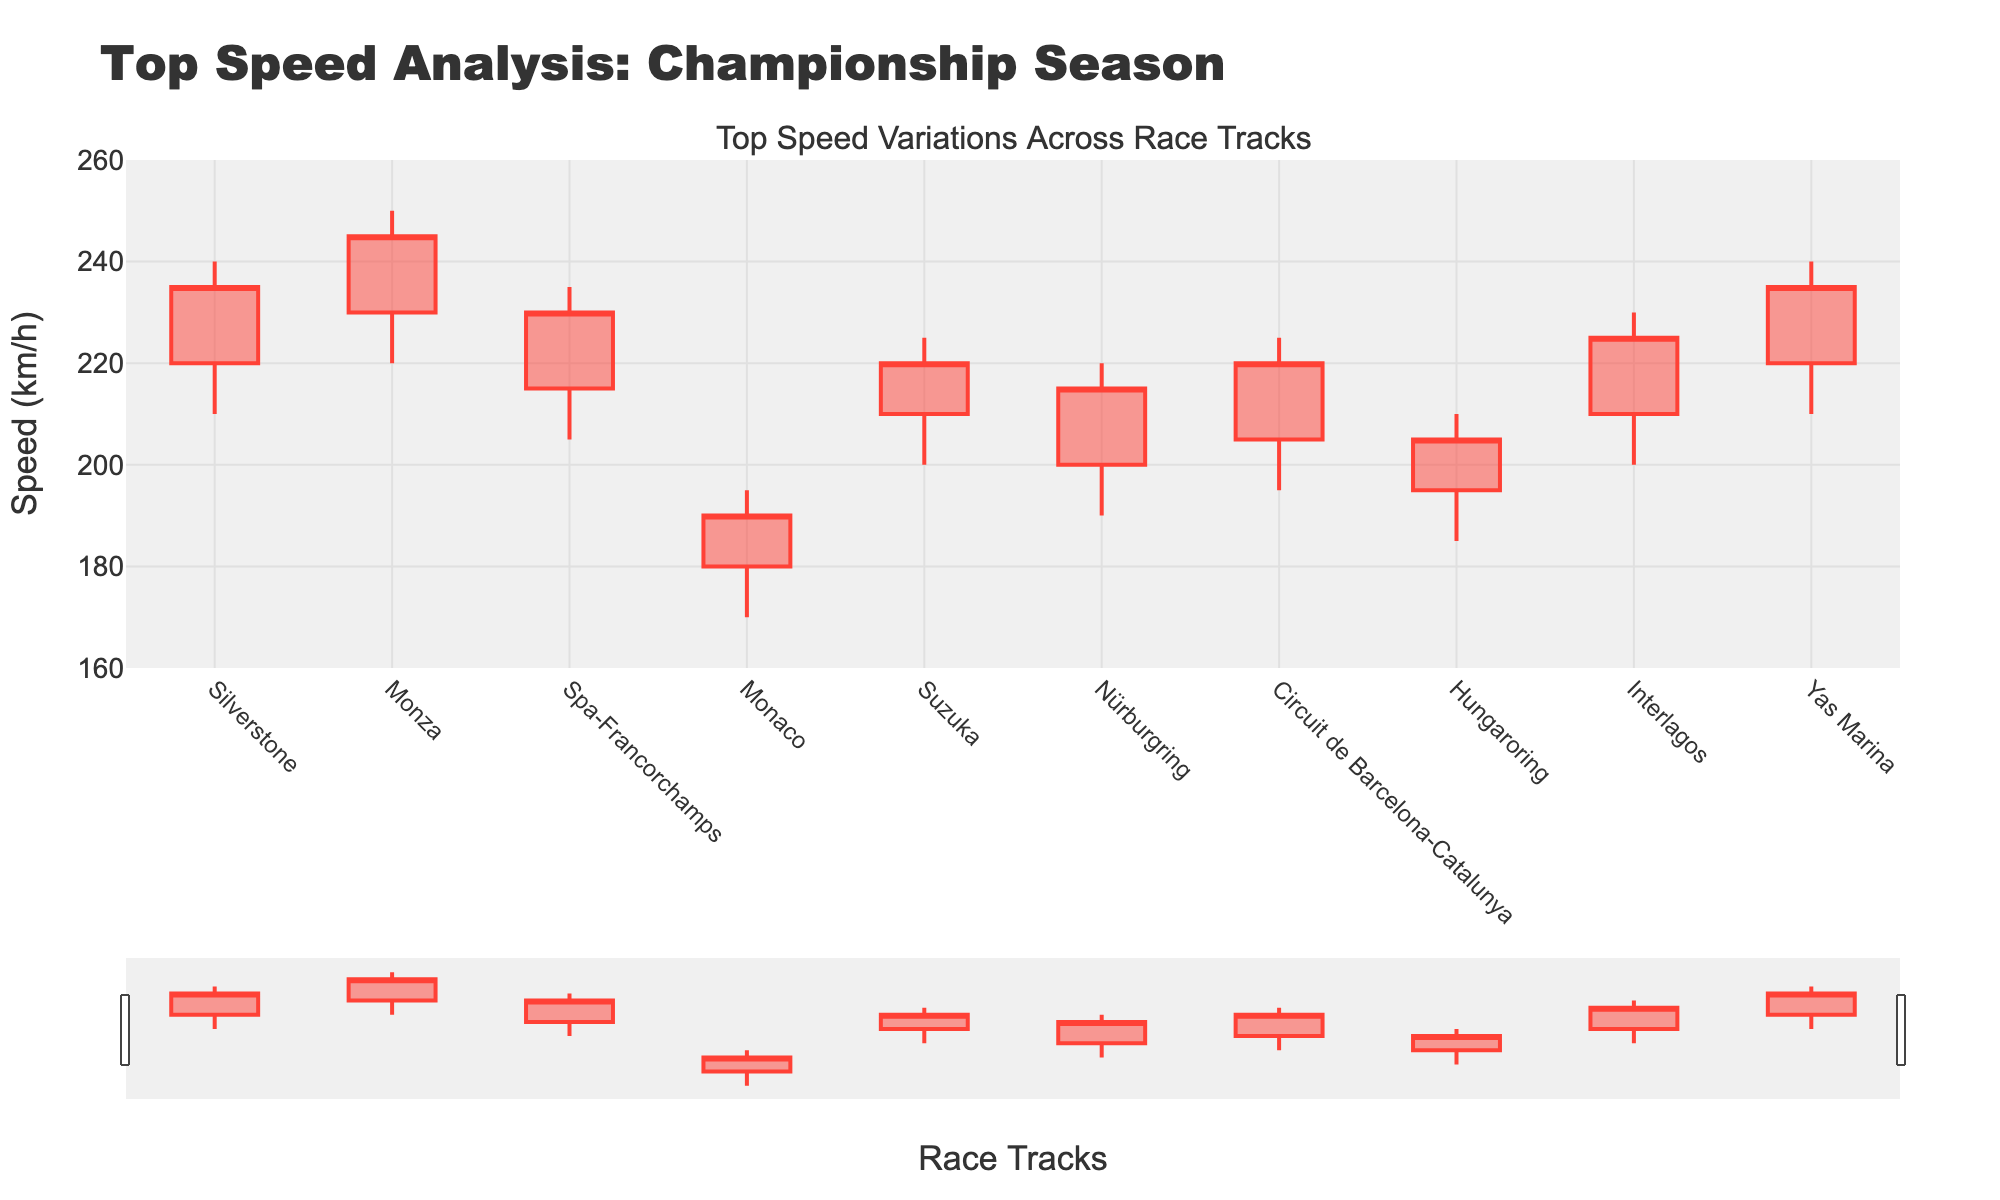What's the title of the plot? The title of a plot is typically displayed at the top. Here, it reads "Top Speed Analysis: Championship Season".
Answer: Top Speed Analysis: Championship Season What is the highest speed recorded and at which track did it occur? The highest speed is represented by the peak of the candlestick. It occurred at Monza where the highest recorded speed is 250 km/h.
Answer: Monza, 250 km/h Which track had the lowest closing speed? The closing speed for each track is represented by the top or bottom of the candlestick's body. The lowest closing speed is at Monaco with 190 km/h.
Answer: Monaco, 190 km/h What is the speed range at Suzuka? The speed range can be calculated by the difference between the high and low speeds. At Suzuka, it ranges from 225 km/h to 200 km/h.
Answer: 25 km/h Which track had the greatest variation in top speed? The greatest variation is indicated by the candlestick with the longest length from high to low. Monza has the range from 250 km/h to 220 km/h, which is a 30 km/h variation.
Answer: Monza, 30 km/h How many tracks have a closing speed above 220 km/h? By looking at the closing speeds (the top or bottom of the candlestick body), we identify Silverstone, Monza, Suzuka, Circuit de Barcelona-Catalunya, Interlagos, and Yas Marina, totaling six tracks.
Answer: Six tracks Which track shows the least variation in speed? The smallest variation in speed can be identified by the shortest candlestick. Monaco has the range from 195 km/h to 170 km/h, indicating a 25 km/h variation.
Answer: Monaco, 25 km/h What is the average opening speed across all tracks? Adding all opening speeds (220, 230, 215, 180, 210, 200, 205, 195, 210, 220) then dividing by the number of tracks (10) yields an average of 209.5 km/h.
Answer: 209.5 km/h Compare the opening speeds of Silverstone and Spa-Francorchamps. Which is higher and by how much? Silverstone's opening speed is 220 km/h and Spa-Francorchamps' is 215 km/h. Silverstone's is higher by 5 km/h.
Answer: Silverstone, 5 km/h What is the median closing speed of all tracks? Sorting the closing speeds (190, 205, 215, 220, 220, 225, 230, 235, 235, 245) and finding the middle value (or the average of the two middle values since there are 10 tracks) gives us (220 + 225) / 2 = 222.5 km/h.
Answer: 222.5 km/h 